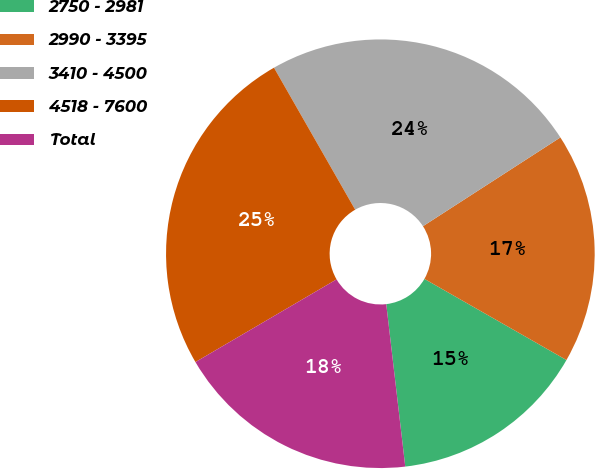Convert chart to OTSL. <chart><loc_0><loc_0><loc_500><loc_500><pie_chart><fcel>2750 - 2981<fcel>2990 - 3395<fcel>3410 - 4500<fcel>4518 - 7600<fcel>Total<nl><fcel>14.89%<fcel>17.39%<fcel>24.14%<fcel>25.17%<fcel>18.42%<nl></chart> 